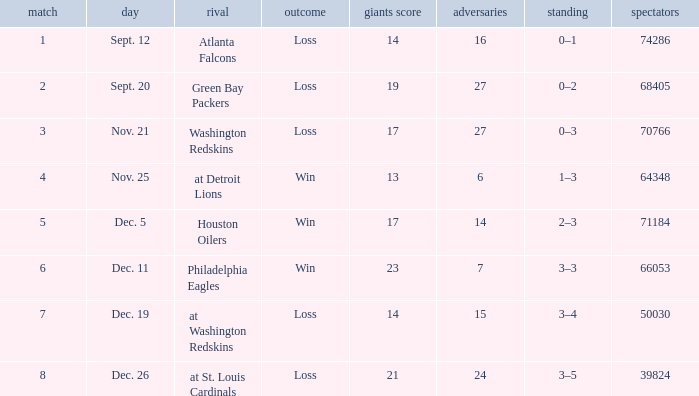What is the record when the opponent is washington redskins? 0–3. Could you parse the entire table as a dict? {'header': ['match', 'day', 'rival', 'outcome', 'giants score', 'adversaries', 'standing', 'spectators'], 'rows': [['1', 'Sept. 12', 'Atlanta Falcons', 'Loss', '14', '16', '0–1', '74286'], ['2', 'Sept. 20', 'Green Bay Packers', 'Loss', '19', '27', '0–2', '68405'], ['3', 'Nov. 21', 'Washington Redskins', 'Loss', '17', '27', '0–3', '70766'], ['4', 'Nov. 25', 'at Detroit Lions', 'Win', '13', '6', '1–3', '64348'], ['5', 'Dec. 5', 'Houston Oilers', 'Win', '17', '14', '2–3', '71184'], ['6', 'Dec. 11', 'Philadelphia Eagles', 'Win', '23', '7', '3–3', '66053'], ['7', 'Dec. 19', 'at Washington Redskins', 'Loss', '14', '15', '3–4', '50030'], ['8', 'Dec. 26', 'at St. Louis Cardinals', 'Loss', '21', '24', '3–5', '39824']]} 